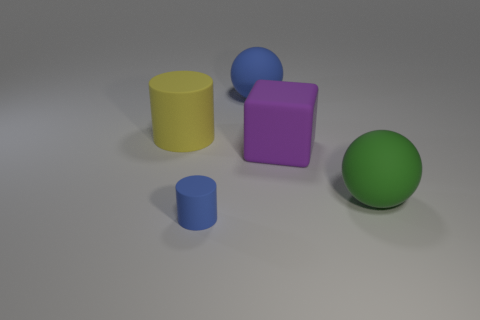What color is the rubber cylinder that is the same size as the matte cube? The rubber cylinder sharing the same size with the matte cube is yellow. Although both the cylinder and the cube have distinctly different shapes, their color and size are important aspects that help to distinguish them from the other objects in the scene. 